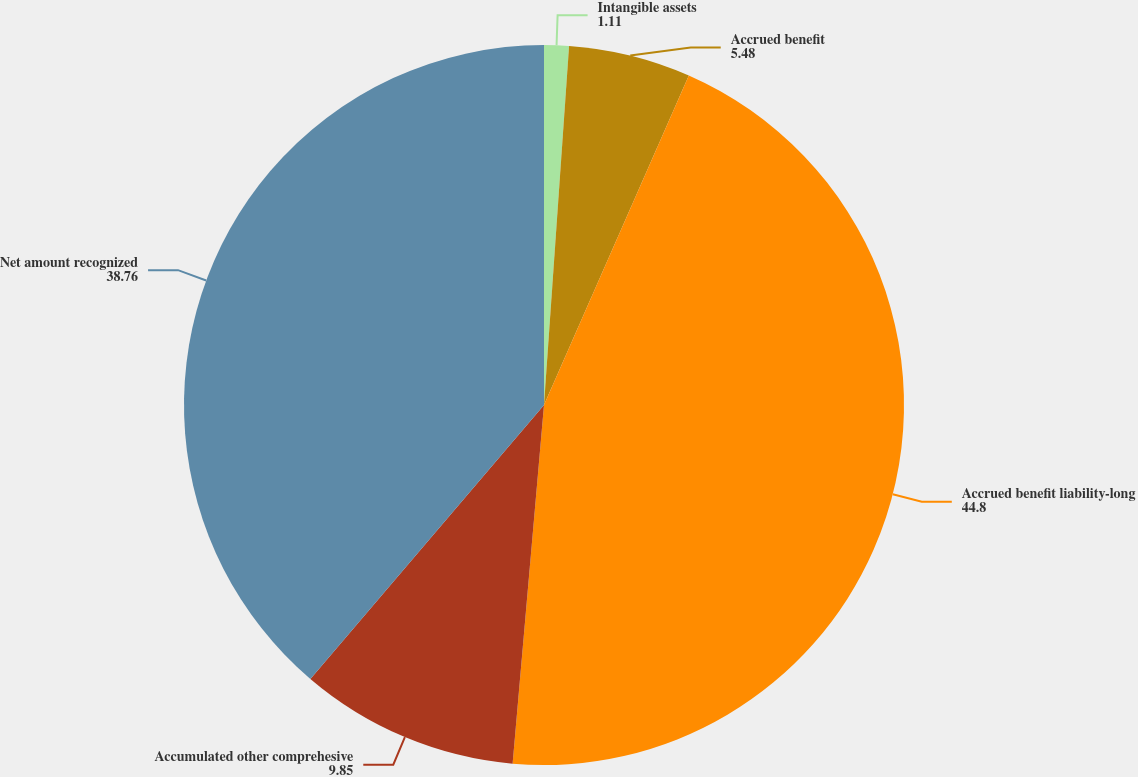Convert chart to OTSL. <chart><loc_0><loc_0><loc_500><loc_500><pie_chart><fcel>Intangible assets<fcel>Accrued benefit<fcel>Accrued benefit liability-long<fcel>Accumulated other comprehesive<fcel>Net amount recognized<nl><fcel>1.11%<fcel>5.48%<fcel>44.8%<fcel>9.85%<fcel>38.76%<nl></chart> 